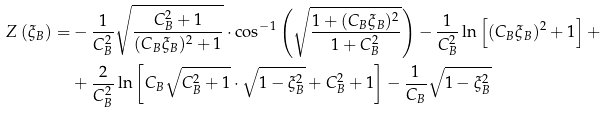Convert formula to latex. <formula><loc_0><loc_0><loc_500><loc_500>Z \left ( \xi _ { B } \right ) = & - \frac { 1 } { C ^ { 2 } _ { B } } \sqrt { \frac { C ^ { 2 } _ { B } + 1 } { ( C _ { B } \xi _ { B } ) ^ { 2 } + 1 } } \cdot \cos ^ { - 1 } \left ( \sqrt { \frac { 1 + ( C _ { B } \xi _ { B } ) ^ { 2 } } { 1 + C ^ { 2 } _ { B } } } \right ) - \frac { 1 } { C ^ { 2 } _ { B } } \ln \left [ ( C _ { B } \xi _ { B } ) ^ { 2 } + 1 \right ] + \\ & + \frac { 2 } { C ^ { 2 } _ { B } } \ln \left [ C _ { B } \sqrt { C ^ { 2 } _ { B } + 1 } \cdot \sqrt { 1 - \xi ^ { 2 } _ { B } } + C ^ { 2 } _ { B } + 1 \right ] - \frac { 1 } { C _ { B } } \sqrt { 1 - \xi ^ { 2 } _ { B } } \\</formula> 